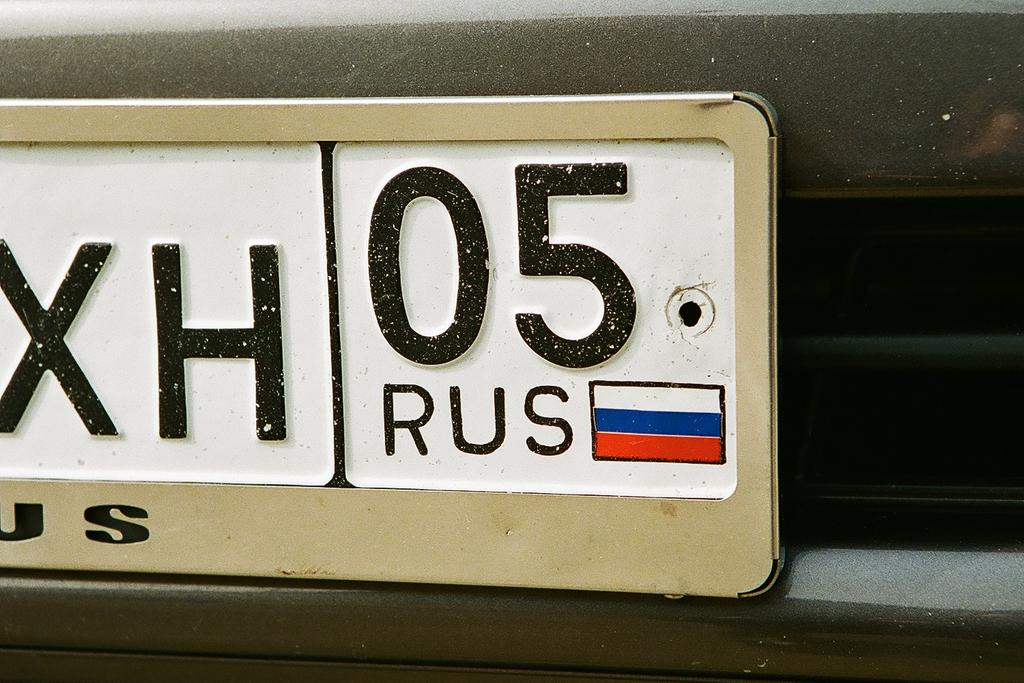<image>
Give a short and clear explanation of the subsequent image. A real Russian license plate with the following numbers: XH05. 